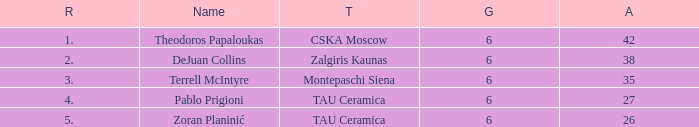What is the least number of assists among players ranked 2? 38.0. 